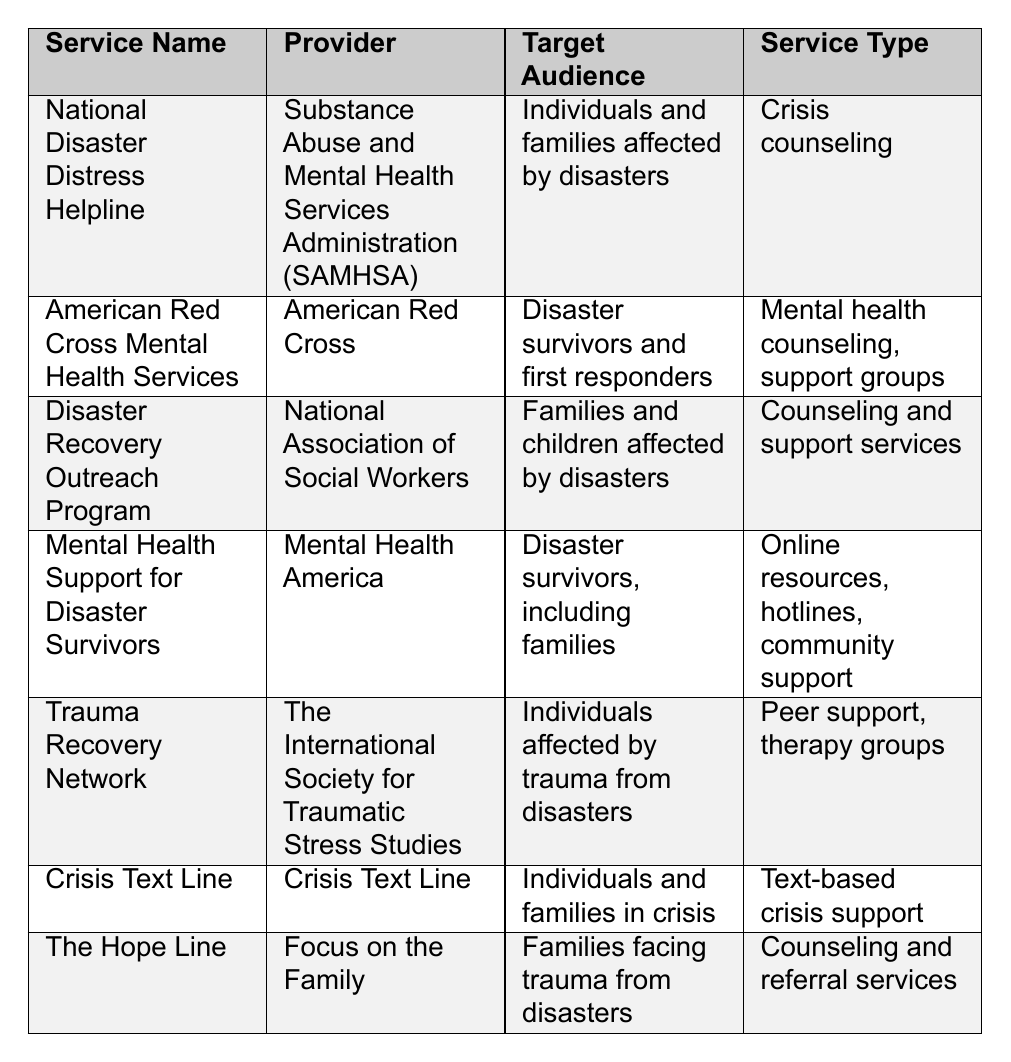What is the name of the service provided by SAMHSA? The table lists the name of the service as "National Disaster Distress Helpline" under the "Service Name" column, provided by SAMHSA.
Answer: National Disaster Distress Helpline Which service is aimed specifically at families and children affected by disasters? The "Disaster Recovery Outreach Program" is targeted towards families and children, as mentioned in the "Target Audience" column.
Answer: Disaster Recovery Outreach Program How many services listed provide mental health counseling? The table shows two services that provide mental health counseling: "American Red Cross Mental Health Services" and "The Hope Line." Counting these gives a total of 2.
Answer: 2 What type of service does the Crisis Text Line provide? The "Service Type" column for the "Crisis Text Line" indicates it offers text-based crisis support, which implies fast, accessible help via text messages.
Answer: Text-based crisis support Is there a service that provides peer support for disaster survivors? Yes, the "Trauma Recovery Network" offers peer support as part of its services, as mentioned in the "Service Type" column.
Answer: Yes Which provider offers the service that includes online resources and hotlines? The "Mental Health Support for Disaster Survivors" service is provided by "Mental Health America," which includes online resources and hotlines in its services.
Answer: Mental Health America What is the contact method for the Crisis Text Line? The contact method listed for the "Crisis Text Line" is to text "HOME" to the number 741741, as shown in the "Contact Information" column.
Answer: Text HOME to 741741 Which services have a focus on children and families? "Disaster Recovery Outreach Program" focuses specifically on families and children, while "Mental Health Support for Disaster Survivors" is also aimed at families. This indicates at least two services focus on this demographic.
Answer: 2 services What are the service types provided by the American Red Cross? The "American Red Cross Mental Health Services" offers two types of services: mental health counseling and support groups, as per the "Service Type" column.
Answer: Mental health counseling, support groups Which service has no contact information listed? The table indicates that the "Trauma Recovery Network" does not have specific contact information provided, as seen in the relevant column.
Answer: Trauma Recovery Network What is the common target audience for most of these services? The common target audience for most of these services is individuals and families affected by disasters, which encompasses multiple entries in the table.
Answer: Individuals and families affected by disasters Which service is provided by Focus on the Family? "The Hope Line" is the service provided by "Focus on the Family," as indicated under the "Service Name" and "Provider" columns.
Answer: The Hope Line Are there more services aimed at individuals than families? Analyzing the table reveals that several services are aimed at families (4) and several at individuals (3). Thus, services aimed at families outnumber those for individuals.
Answer: No 